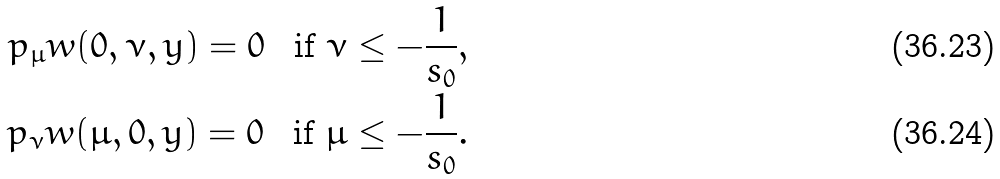<formula> <loc_0><loc_0><loc_500><loc_500>\ p _ { \mu } w ( 0 , \nu , y ) = 0 \, \ \text { if } \nu \leq - \frac { 1 } { s _ { 0 } } , \\ \ p _ { \nu } w ( \mu , 0 , y ) = 0 \, \ \text { if } \mu \leq - \frac { 1 } { s _ { 0 } } .</formula> 